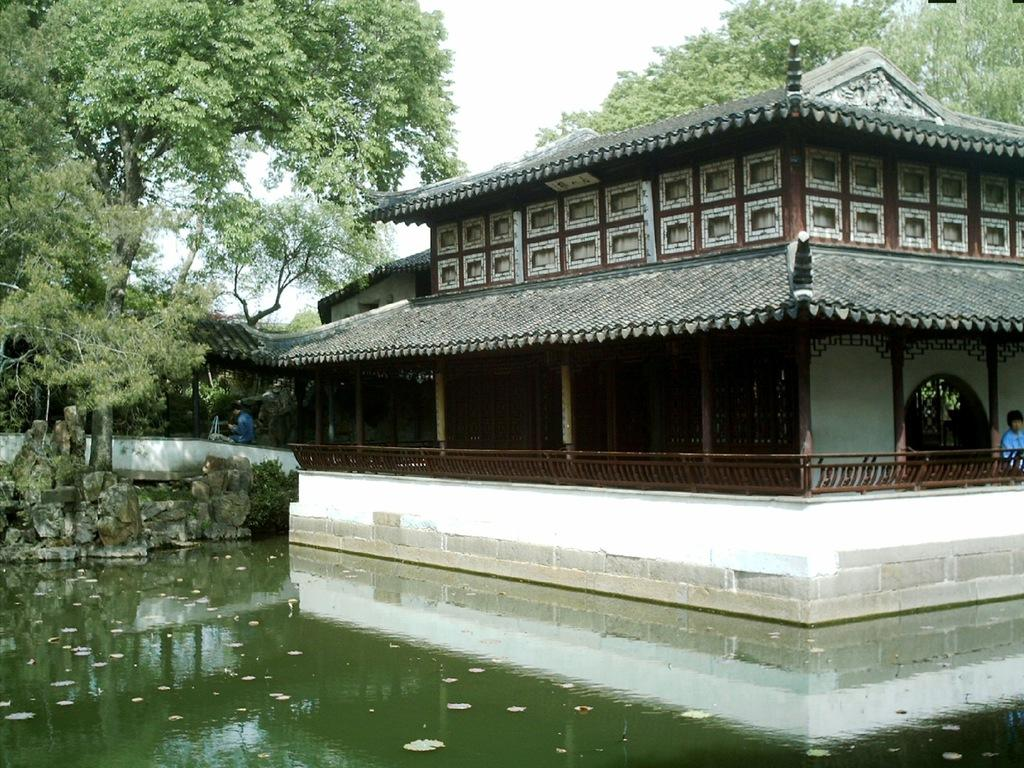What is present at the bottom of the image? There is water at the bottom of the image. What structure can be seen on the right side of the image? There is a house on the right side of the image. What type of vegetation is on the left side of the image? There are trees on the left side of the image. What is visible at the top of the image? The sky is visible at the top of the image. How many toads are sitting on the roof of the house in the image? There are no toads present in the image; it features a house, trees, water, and sky. What color is the wrist of the person in the image? There is no person present in the image, so it is not possible to determine the color of their wrist. 